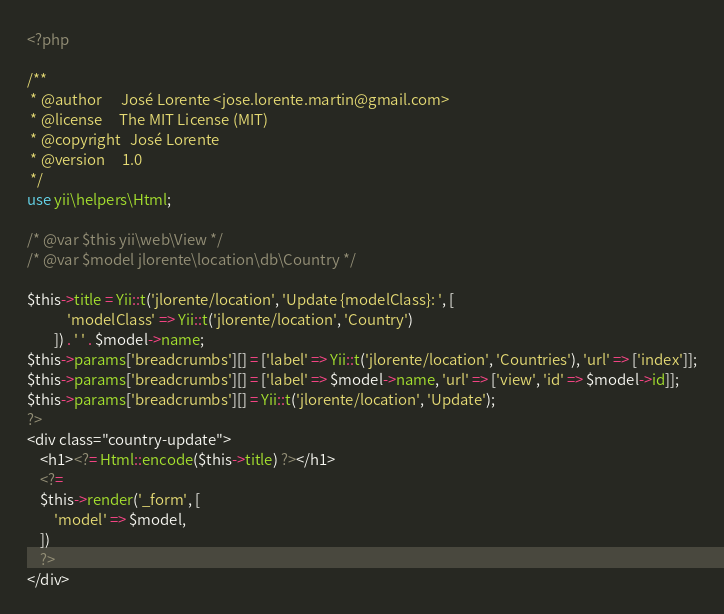<code> <loc_0><loc_0><loc_500><loc_500><_PHP_><?php

/**
 * @author      José Lorente <jose.lorente.martin@gmail.com>
 * @license     The MIT License (MIT)
 * @copyright   José Lorente
 * @version     1.0
 */
use yii\helpers\Html;

/* @var $this yii\web\View */
/* @var $model jlorente\location\db\Country */

$this->title = Yii::t('jlorente/location', 'Update {modelClass}: ', [
            'modelClass' => Yii::t('jlorente/location', 'Country')
        ]) . ' ' . $model->name;
$this->params['breadcrumbs'][] = ['label' => Yii::t('jlorente/location', 'Countries'), 'url' => ['index']];
$this->params['breadcrumbs'][] = ['label' => $model->name, 'url' => ['view', 'id' => $model->id]];
$this->params['breadcrumbs'][] = Yii::t('jlorente/location', 'Update');
?>
<div class="country-update">
    <h1><?= Html::encode($this->title) ?></h1>
    <?=
    $this->render('_form', [
        'model' => $model,
    ])
    ?>
</div>
</code> 